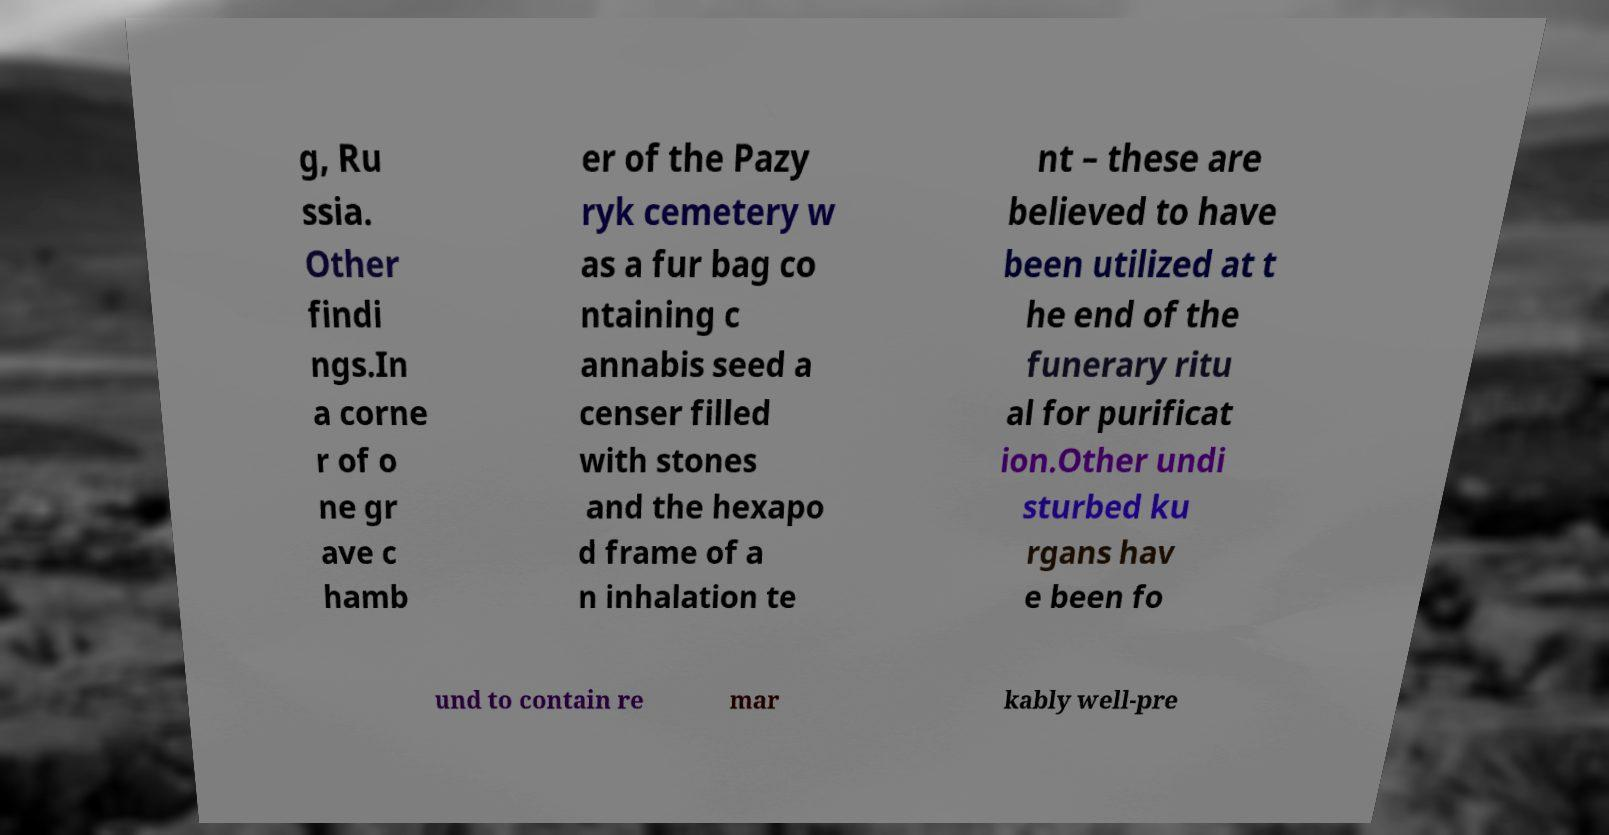Please read and relay the text visible in this image. What does it say? g, Ru ssia. Other findi ngs.In a corne r of o ne gr ave c hamb er of the Pazy ryk cemetery w as a fur bag co ntaining c annabis seed a censer filled with stones and the hexapo d frame of a n inhalation te nt – these are believed to have been utilized at t he end of the funerary ritu al for purificat ion.Other undi sturbed ku rgans hav e been fo und to contain re mar kably well-pre 